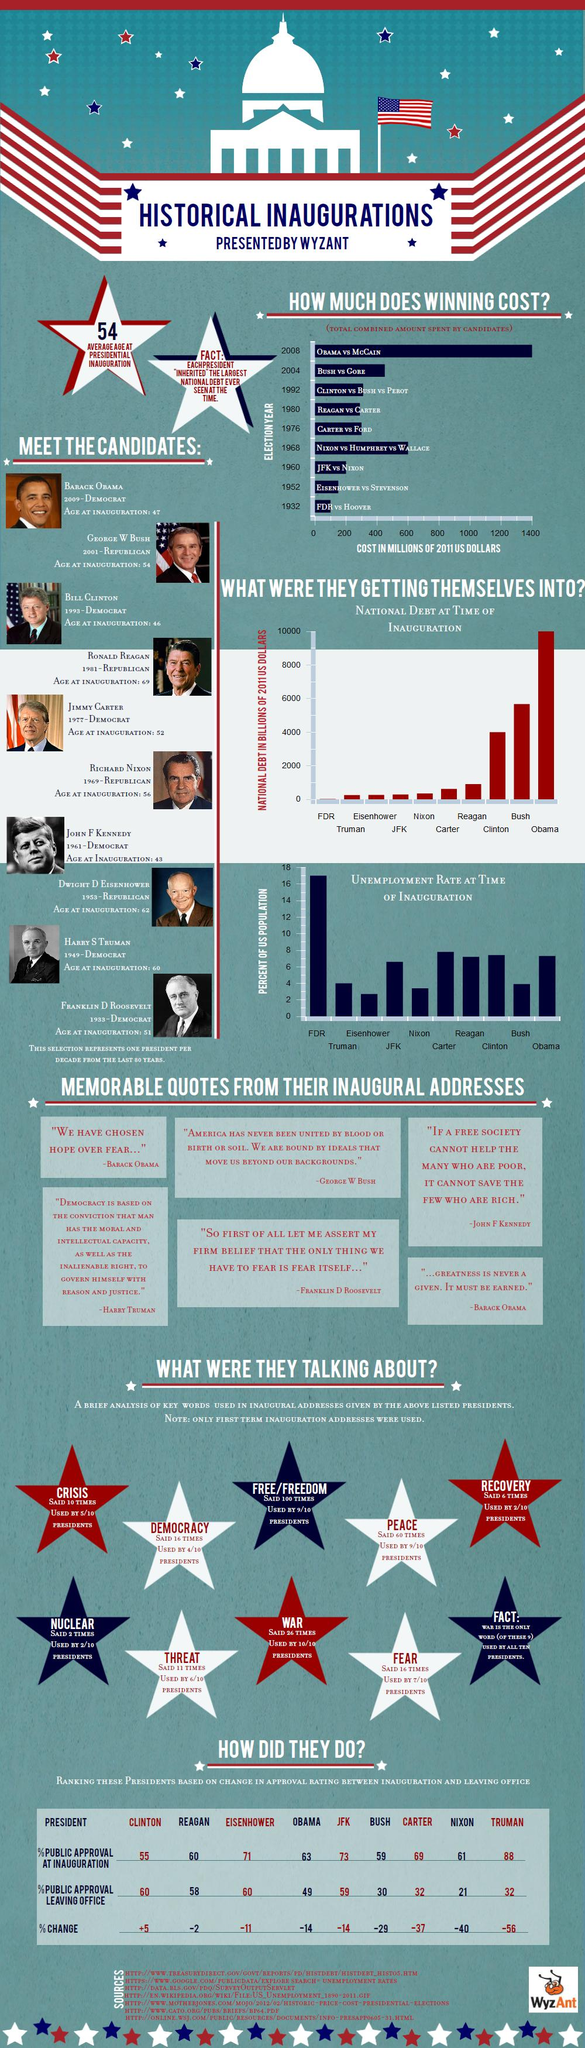Mention a couple of crucial points in this snapshot. The difference in the percentage of approval at inauguration between President Truman and President Clinton was 33%. There are ten images of American presidents provided. The percentage difference in public approval while leaving office between former US presidents Dwight D. Eisenhower and Bill Clinton falls within the range of 0%. During the presidencies of Franklin D. Roosevelt and Barack Obama, the unemployment rate varied significantly, with FDR's administration experiencing an average of 10 percent unemployment and Obama's administration experiencing an average of around 5 percent unemployment. During the inaugural addresses, a total of 10 common keywords were used. 